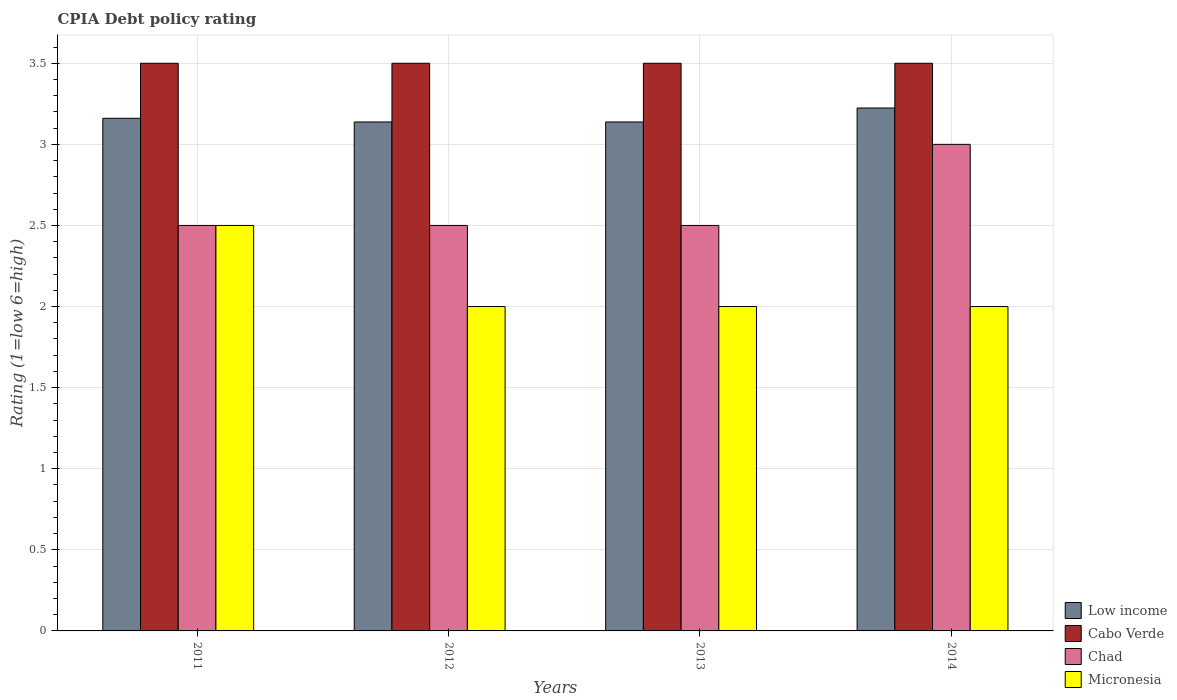Across all years, what is the maximum CPIA rating in Low income?
Provide a short and direct response. 3.22. What is the total CPIA rating in Chad in the graph?
Your answer should be compact. 10.5. What is the difference between the CPIA rating in Chad in 2011 and that in 2014?
Provide a short and direct response. -0.5. What is the average CPIA rating in Micronesia per year?
Make the answer very short. 2.12. In the year 2011, what is the difference between the CPIA rating in Low income and CPIA rating in Cabo Verde?
Give a very brief answer. -0.34. In how many years, is the CPIA rating in Micronesia greater than 1?
Provide a short and direct response. 4. What is the ratio of the CPIA rating in Low income in 2013 to that in 2014?
Offer a terse response. 0.97. Is the CPIA rating in Micronesia in 2011 less than that in 2013?
Provide a succinct answer. No. Is the sum of the CPIA rating in Cabo Verde in 2013 and 2014 greater than the maximum CPIA rating in Micronesia across all years?
Give a very brief answer. Yes. Is it the case that in every year, the sum of the CPIA rating in Micronesia and CPIA rating in Chad is greater than the sum of CPIA rating in Cabo Verde and CPIA rating in Low income?
Your answer should be very brief. No. What does the 3rd bar from the left in 2014 represents?
Your answer should be very brief. Chad. How many bars are there?
Provide a short and direct response. 16. What is the difference between two consecutive major ticks on the Y-axis?
Provide a short and direct response. 0.5. Does the graph contain any zero values?
Offer a terse response. No. Does the graph contain grids?
Your answer should be very brief. Yes. How many legend labels are there?
Ensure brevity in your answer.  4. What is the title of the graph?
Your answer should be very brief. CPIA Debt policy rating. What is the Rating (1=low 6=high) in Low income in 2011?
Your answer should be compact. 3.16. What is the Rating (1=low 6=high) of Low income in 2012?
Your answer should be very brief. 3.14. What is the Rating (1=low 6=high) of Cabo Verde in 2012?
Offer a very short reply. 3.5. What is the Rating (1=low 6=high) in Chad in 2012?
Keep it short and to the point. 2.5. What is the Rating (1=low 6=high) of Micronesia in 2012?
Offer a terse response. 2. What is the Rating (1=low 6=high) of Low income in 2013?
Make the answer very short. 3.14. What is the Rating (1=low 6=high) of Cabo Verde in 2013?
Offer a very short reply. 3.5. What is the Rating (1=low 6=high) in Micronesia in 2013?
Provide a succinct answer. 2. What is the Rating (1=low 6=high) of Low income in 2014?
Your answer should be compact. 3.22. What is the Rating (1=low 6=high) in Chad in 2014?
Your answer should be very brief. 3. What is the Rating (1=low 6=high) of Micronesia in 2014?
Your answer should be very brief. 2. Across all years, what is the maximum Rating (1=low 6=high) of Low income?
Make the answer very short. 3.22. Across all years, what is the maximum Rating (1=low 6=high) in Chad?
Provide a short and direct response. 3. Across all years, what is the maximum Rating (1=low 6=high) in Micronesia?
Give a very brief answer. 2.5. Across all years, what is the minimum Rating (1=low 6=high) of Low income?
Offer a terse response. 3.14. Across all years, what is the minimum Rating (1=low 6=high) of Cabo Verde?
Provide a short and direct response. 3.5. What is the total Rating (1=low 6=high) in Low income in the graph?
Keep it short and to the point. 12.66. What is the total Rating (1=low 6=high) in Cabo Verde in the graph?
Offer a terse response. 14. What is the difference between the Rating (1=low 6=high) of Low income in 2011 and that in 2012?
Your answer should be compact. 0.02. What is the difference between the Rating (1=low 6=high) of Low income in 2011 and that in 2013?
Provide a succinct answer. 0.02. What is the difference between the Rating (1=low 6=high) in Chad in 2011 and that in 2013?
Provide a short and direct response. 0. What is the difference between the Rating (1=low 6=high) of Micronesia in 2011 and that in 2013?
Make the answer very short. 0.5. What is the difference between the Rating (1=low 6=high) of Low income in 2011 and that in 2014?
Make the answer very short. -0.06. What is the difference between the Rating (1=low 6=high) in Chad in 2011 and that in 2014?
Provide a succinct answer. -0.5. What is the difference between the Rating (1=low 6=high) in Micronesia in 2011 and that in 2014?
Provide a short and direct response. 0.5. What is the difference between the Rating (1=low 6=high) of Chad in 2012 and that in 2013?
Ensure brevity in your answer.  0. What is the difference between the Rating (1=low 6=high) in Low income in 2012 and that in 2014?
Your answer should be compact. -0.09. What is the difference between the Rating (1=low 6=high) of Low income in 2013 and that in 2014?
Provide a short and direct response. -0.09. What is the difference between the Rating (1=low 6=high) of Cabo Verde in 2013 and that in 2014?
Ensure brevity in your answer.  0. What is the difference between the Rating (1=low 6=high) of Chad in 2013 and that in 2014?
Offer a terse response. -0.5. What is the difference between the Rating (1=low 6=high) of Micronesia in 2013 and that in 2014?
Provide a succinct answer. 0. What is the difference between the Rating (1=low 6=high) in Low income in 2011 and the Rating (1=low 6=high) in Cabo Verde in 2012?
Provide a succinct answer. -0.34. What is the difference between the Rating (1=low 6=high) in Low income in 2011 and the Rating (1=low 6=high) in Chad in 2012?
Your response must be concise. 0.66. What is the difference between the Rating (1=low 6=high) in Low income in 2011 and the Rating (1=low 6=high) in Micronesia in 2012?
Provide a succinct answer. 1.16. What is the difference between the Rating (1=low 6=high) of Cabo Verde in 2011 and the Rating (1=low 6=high) of Chad in 2012?
Give a very brief answer. 1. What is the difference between the Rating (1=low 6=high) in Low income in 2011 and the Rating (1=low 6=high) in Cabo Verde in 2013?
Offer a terse response. -0.34. What is the difference between the Rating (1=low 6=high) of Low income in 2011 and the Rating (1=low 6=high) of Chad in 2013?
Your response must be concise. 0.66. What is the difference between the Rating (1=low 6=high) of Low income in 2011 and the Rating (1=low 6=high) of Micronesia in 2013?
Give a very brief answer. 1.16. What is the difference between the Rating (1=low 6=high) in Cabo Verde in 2011 and the Rating (1=low 6=high) in Chad in 2013?
Provide a short and direct response. 1. What is the difference between the Rating (1=low 6=high) in Low income in 2011 and the Rating (1=low 6=high) in Cabo Verde in 2014?
Your answer should be compact. -0.34. What is the difference between the Rating (1=low 6=high) of Low income in 2011 and the Rating (1=low 6=high) of Chad in 2014?
Provide a short and direct response. 0.16. What is the difference between the Rating (1=low 6=high) in Low income in 2011 and the Rating (1=low 6=high) in Micronesia in 2014?
Offer a very short reply. 1.16. What is the difference between the Rating (1=low 6=high) in Cabo Verde in 2011 and the Rating (1=low 6=high) in Micronesia in 2014?
Make the answer very short. 1.5. What is the difference between the Rating (1=low 6=high) of Low income in 2012 and the Rating (1=low 6=high) of Cabo Verde in 2013?
Keep it short and to the point. -0.36. What is the difference between the Rating (1=low 6=high) of Low income in 2012 and the Rating (1=low 6=high) of Chad in 2013?
Your answer should be very brief. 0.64. What is the difference between the Rating (1=low 6=high) of Low income in 2012 and the Rating (1=low 6=high) of Micronesia in 2013?
Ensure brevity in your answer.  1.14. What is the difference between the Rating (1=low 6=high) in Cabo Verde in 2012 and the Rating (1=low 6=high) in Chad in 2013?
Offer a very short reply. 1. What is the difference between the Rating (1=low 6=high) in Chad in 2012 and the Rating (1=low 6=high) in Micronesia in 2013?
Provide a short and direct response. 0.5. What is the difference between the Rating (1=low 6=high) of Low income in 2012 and the Rating (1=low 6=high) of Cabo Verde in 2014?
Offer a terse response. -0.36. What is the difference between the Rating (1=low 6=high) in Low income in 2012 and the Rating (1=low 6=high) in Chad in 2014?
Your response must be concise. 0.14. What is the difference between the Rating (1=low 6=high) of Low income in 2012 and the Rating (1=low 6=high) of Micronesia in 2014?
Provide a succinct answer. 1.14. What is the difference between the Rating (1=low 6=high) in Cabo Verde in 2012 and the Rating (1=low 6=high) in Chad in 2014?
Make the answer very short. 0.5. What is the difference between the Rating (1=low 6=high) of Chad in 2012 and the Rating (1=low 6=high) of Micronesia in 2014?
Give a very brief answer. 0.5. What is the difference between the Rating (1=low 6=high) in Low income in 2013 and the Rating (1=low 6=high) in Cabo Verde in 2014?
Make the answer very short. -0.36. What is the difference between the Rating (1=low 6=high) in Low income in 2013 and the Rating (1=low 6=high) in Chad in 2014?
Give a very brief answer. 0.14. What is the difference between the Rating (1=low 6=high) in Low income in 2013 and the Rating (1=low 6=high) in Micronesia in 2014?
Provide a succinct answer. 1.14. What is the difference between the Rating (1=low 6=high) in Cabo Verde in 2013 and the Rating (1=low 6=high) in Chad in 2014?
Your answer should be very brief. 0.5. What is the difference between the Rating (1=low 6=high) in Cabo Verde in 2013 and the Rating (1=low 6=high) in Micronesia in 2014?
Ensure brevity in your answer.  1.5. What is the difference between the Rating (1=low 6=high) of Chad in 2013 and the Rating (1=low 6=high) of Micronesia in 2014?
Give a very brief answer. 0.5. What is the average Rating (1=low 6=high) in Low income per year?
Your response must be concise. 3.17. What is the average Rating (1=low 6=high) in Cabo Verde per year?
Ensure brevity in your answer.  3.5. What is the average Rating (1=low 6=high) of Chad per year?
Provide a short and direct response. 2.62. What is the average Rating (1=low 6=high) in Micronesia per year?
Your answer should be compact. 2.12. In the year 2011, what is the difference between the Rating (1=low 6=high) in Low income and Rating (1=low 6=high) in Cabo Verde?
Provide a succinct answer. -0.34. In the year 2011, what is the difference between the Rating (1=low 6=high) of Low income and Rating (1=low 6=high) of Chad?
Make the answer very short. 0.66. In the year 2011, what is the difference between the Rating (1=low 6=high) of Low income and Rating (1=low 6=high) of Micronesia?
Ensure brevity in your answer.  0.66. In the year 2011, what is the difference between the Rating (1=low 6=high) in Cabo Verde and Rating (1=low 6=high) in Micronesia?
Offer a very short reply. 1. In the year 2011, what is the difference between the Rating (1=low 6=high) in Chad and Rating (1=low 6=high) in Micronesia?
Make the answer very short. 0. In the year 2012, what is the difference between the Rating (1=low 6=high) of Low income and Rating (1=low 6=high) of Cabo Verde?
Your response must be concise. -0.36. In the year 2012, what is the difference between the Rating (1=low 6=high) in Low income and Rating (1=low 6=high) in Chad?
Provide a short and direct response. 0.64. In the year 2012, what is the difference between the Rating (1=low 6=high) in Low income and Rating (1=low 6=high) in Micronesia?
Provide a succinct answer. 1.14. In the year 2012, what is the difference between the Rating (1=low 6=high) in Cabo Verde and Rating (1=low 6=high) in Chad?
Offer a very short reply. 1. In the year 2012, what is the difference between the Rating (1=low 6=high) in Chad and Rating (1=low 6=high) in Micronesia?
Make the answer very short. 0.5. In the year 2013, what is the difference between the Rating (1=low 6=high) of Low income and Rating (1=low 6=high) of Cabo Verde?
Your answer should be very brief. -0.36. In the year 2013, what is the difference between the Rating (1=low 6=high) in Low income and Rating (1=low 6=high) in Chad?
Your response must be concise. 0.64. In the year 2013, what is the difference between the Rating (1=low 6=high) in Low income and Rating (1=low 6=high) in Micronesia?
Your answer should be compact. 1.14. In the year 2014, what is the difference between the Rating (1=low 6=high) in Low income and Rating (1=low 6=high) in Cabo Verde?
Make the answer very short. -0.28. In the year 2014, what is the difference between the Rating (1=low 6=high) in Low income and Rating (1=low 6=high) in Chad?
Provide a succinct answer. 0.22. In the year 2014, what is the difference between the Rating (1=low 6=high) in Low income and Rating (1=low 6=high) in Micronesia?
Ensure brevity in your answer.  1.22. What is the ratio of the Rating (1=low 6=high) in Low income in 2011 to that in 2012?
Provide a short and direct response. 1.01. What is the ratio of the Rating (1=low 6=high) in Micronesia in 2011 to that in 2012?
Give a very brief answer. 1.25. What is the ratio of the Rating (1=low 6=high) in Low income in 2011 to that in 2013?
Your response must be concise. 1.01. What is the ratio of the Rating (1=low 6=high) in Micronesia in 2011 to that in 2013?
Give a very brief answer. 1.25. What is the ratio of the Rating (1=low 6=high) in Low income in 2011 to that in 2014?
Provide a succinct answer. 0.98. What is the ratio of the Rating (1=low 6=high) in Chad in 2011 to that in 2014?
Your answer should be very brief. 0.83. What is the ratio of the Rating (1=low 6=high) in Micronesia in 2011 to that in 2014?
Keep it short and to the point. 1.25. What is the ratio of the Rating (1=low 6=high) of Low income in 2012 to that in 2013?
Ensure brevity in your answer.  1. What is the ratio of the Rating (1=low 6=high) in Cabo Verde in 2012 to that in 2013?
Offer a very short reply. 1. What is the ratio of the Rating (1=low 6=high) of Chad in 2012 to that in 2013?
Your response must be concise. 1. What is the ratio of the Rating (1=low 6=high) in Low income in 2012 to that in 2014?
Ensure brevity in your answer.  0.97. What is the ratio of the Rating (1=low 6=high) in Chad in 2012 to that in 2014?
Give a very brief answer. 0.83. What is the ratio of the Rating (1=low 6=high) of Low income in 2013 to that in 2014?
Provide a succinct answer. 0.97. What is the ratio of the Rating (1=low 6=high) of Chad in 2013 to that in 2014?
Make the answer very short. 0.83. What is the difference between the highest and the second highest Rating (1=low 6=high) of Low income?
Offer a very short reply. 0.06. What is the difference between the highest and the second highest Rating (1=low 6=high) in Cabo Verde?
Give a very brief answer. 0. What is the difference between the highest and the lowest Rating (1=low 6=high) of Low income?
Provide a short and direct response. 0.09. What is the difference between the highest and the lowest Rating (1=low 6=high) of Chad?
Your answer should be very brief. 0.5. What is the difference between the highest and the lowest Rating (1=low 6=high) of Micronesia?
Provide a short and direct response. 0.5. 